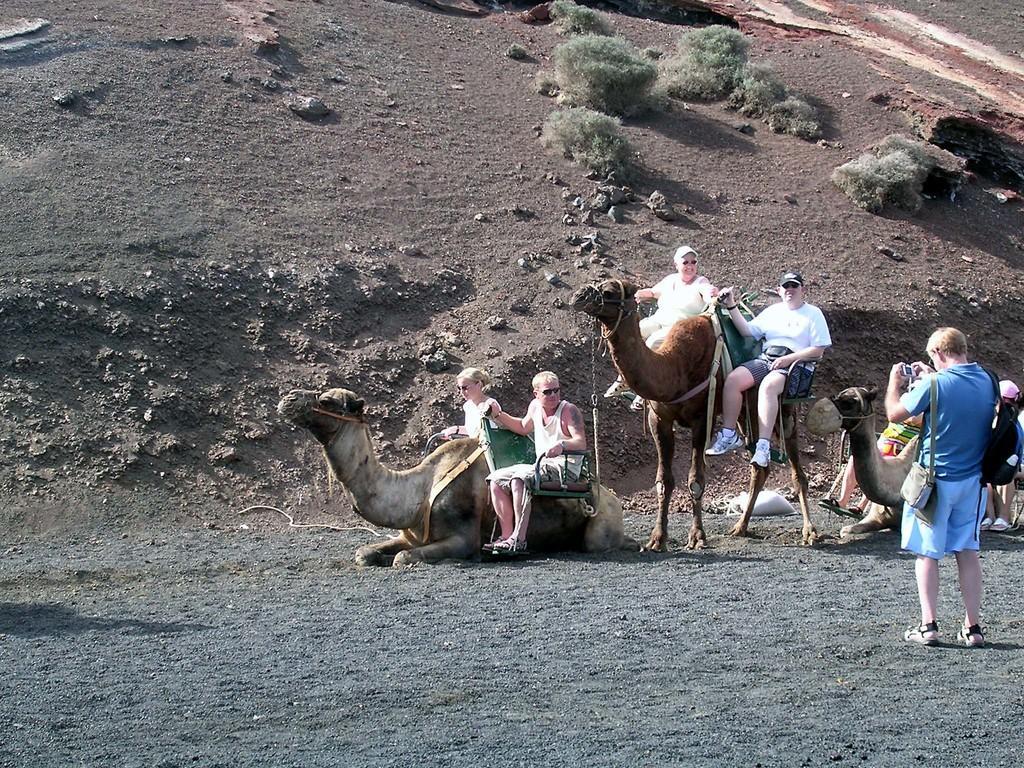In one or two sentences, can you explain what this image depicts? This picture is taken from outside of the city. In this image, on the right side, we can see a man wearing bags and holding the camera in his hand. In the background, we can see a group of people sitting on the camel, rocks, plants and a grass. At the bottom, we can see a land which is in black color. 